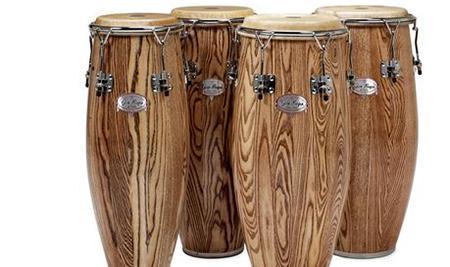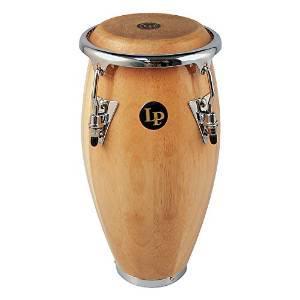The first image is the image on the left, the second image is the image on the right. Given the left and right images, does the statement "there is at least one drum on a platform with wheels" hold true? Answer yes or no. No. The first image is the image on the left, the second image is the image on the right. Considering the images on both sides, is "There are more drums in the image on the left." valid? Answer yes or no. Yes. 